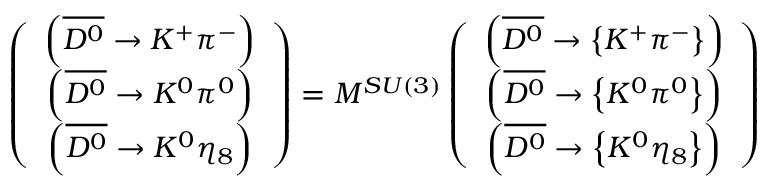<formula> <loc_0><loc_0><loc_500><loc_500>\left ( \begin{array} { c } { { \left ( \overline { { { D ^ { 0 } } } } \rightarrow K ^ { + } \pi ^ { - } \right ) } } \\ { { \left ( \overline { { { D ^ { 0 } } } } \rightarrow K ^ { 0 } \pi ^ { 0 } \right ) } } \\ { { \left ( \overline { { { D ^ { 0 } } } } \rightarrow K ^ { 0 } \eta _ { 8 } \right ) } } \end{array} \right ) = M ^ { S U ( 3 ) } \left ( \begin{array} { c } { { \left ( \overline { { { D ^ { 0 } } } } \rightarrow \left \{ K ^ { + } \pi ^ { - } \right \} \right ) } } \\ { { \left ( \overline { { { D ^ { 0 } } } } \rightarrow \left \{ K ^ { 0 } \pi ^ { 0 } \right \} \right ) } } \\ { { \left ( \overline { { { D ^ { 0 } } } } \rightarrow \left \{ K ^ { 0 } \eta _ { 8 } \right \} \right ) } } \end{array} \right )</formula> 